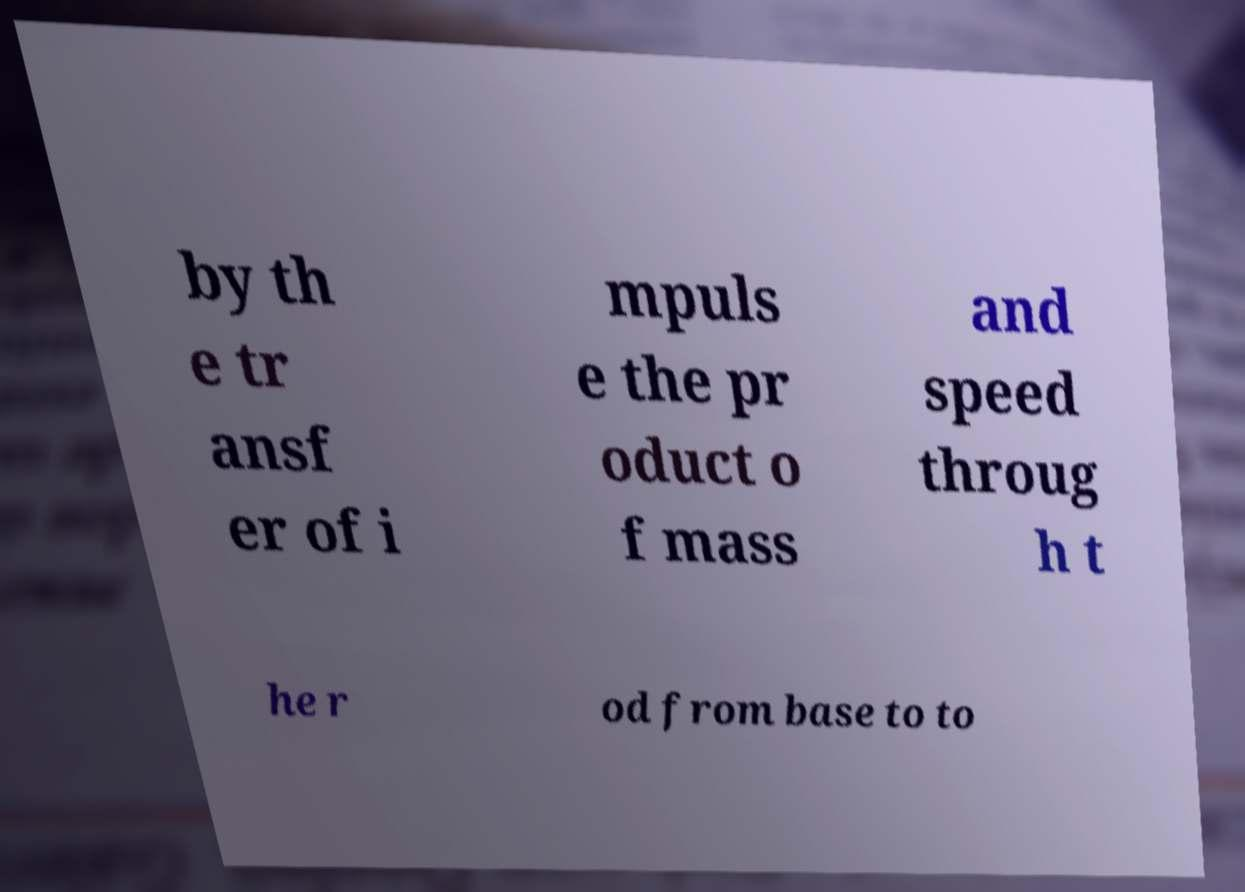Can you accurately transcribe the text from the provided image for me? by th e tr ansf er of i mpuls e the pr oduct o f mass and speed throug h t he r od from base to to 